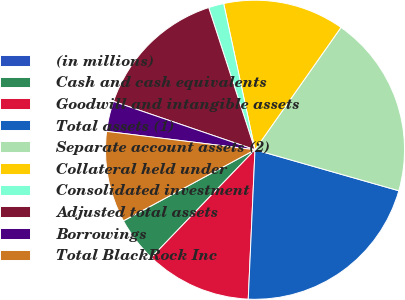Convert chart to OTSL. <chart><loc_0><loc_0><loc_500><loc_500><pie_chart><fcel>(in millions)<fcel>Cash and cash equivalents<fcel>Goodwill and intangible assets<fcel>Total assets (1)<fcel>Separate account assets (2)<fcel>Collateral held under<fcel>Consolidated investment<fcel>Adjusted total assets<fcel>Borrowings<fcel>Total BlackRock Inc<nl><fcel>0.01%<fcel>4.92%<fcel>11.47%<fcel>21.3%<fcel>19.67%<fcel>13.11%<fcel>1.65%<fcel>14.75%<fcel>3.28%<fcel>9.84%<nl></chart> 